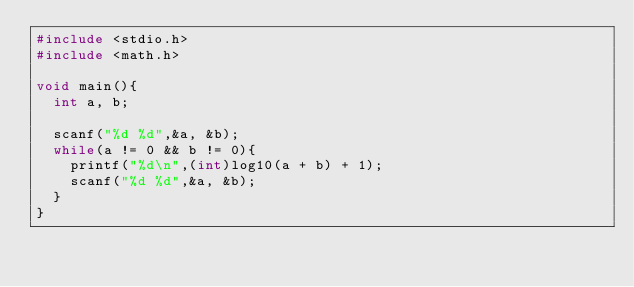<code> <loc_0><loc_0><loc_500><loc_500><_C_>#include <stdio.h>
#include <math.h>

void main(){
	int a, b;

	scanf("%d %d",&a, &b);
	while(a != 0 && b != 0){
		printf("%d\n",(int)log10(a + b) + 1);
		scanf("%d %d",&a, &b);
	}
}</code> 